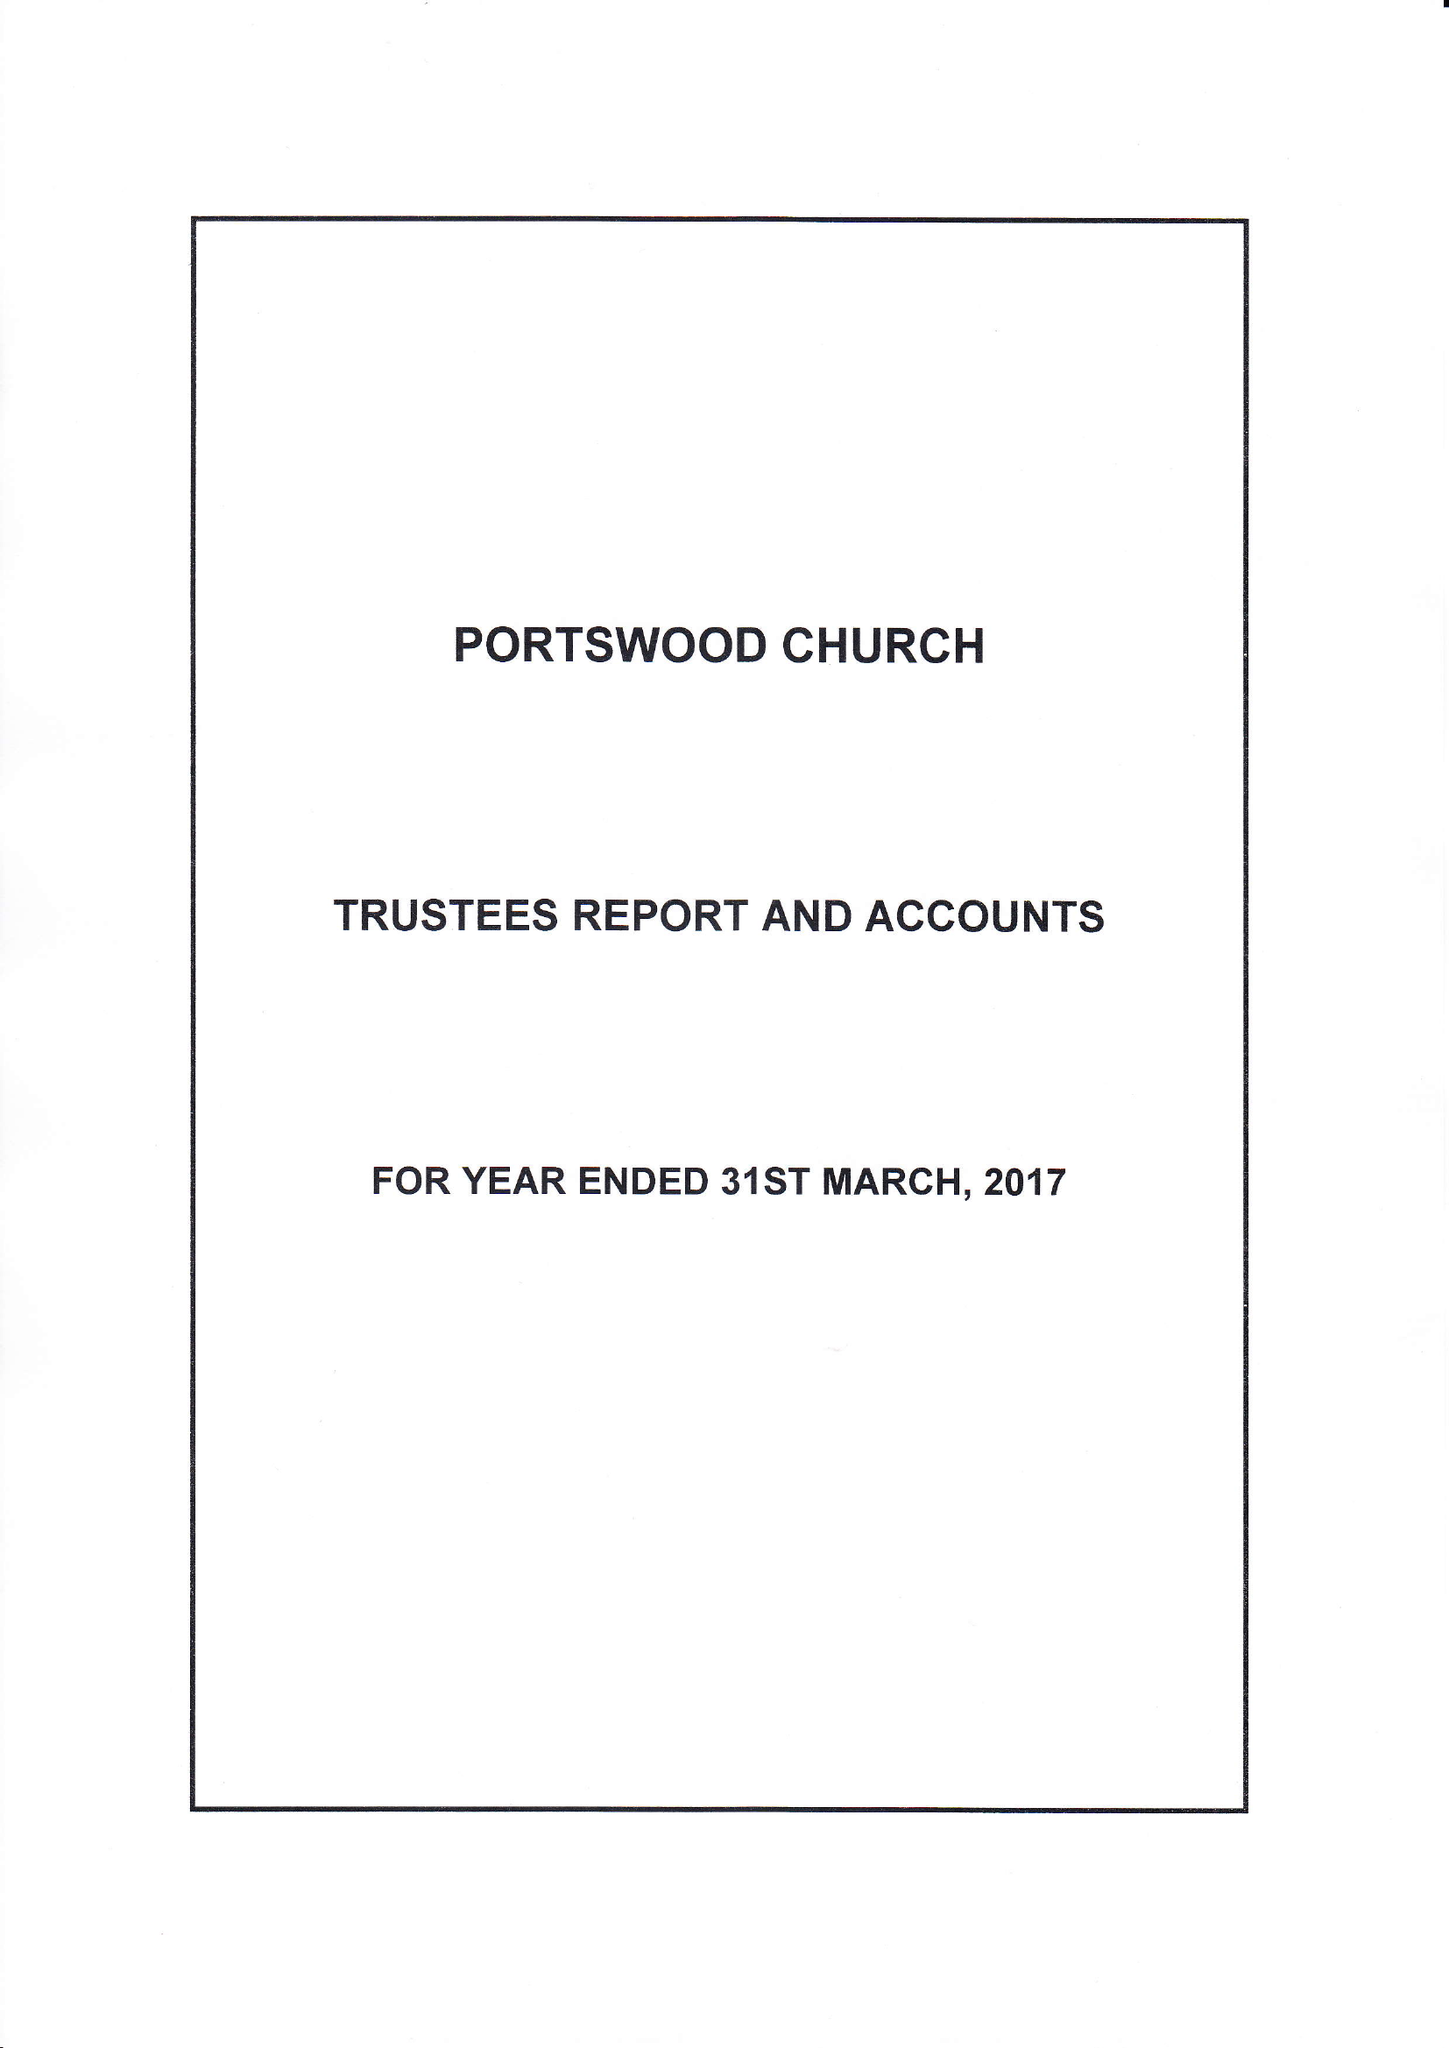What is the value for the address__post_town?
Answer the question using a single word or phrase. SOUTHAMPTON 